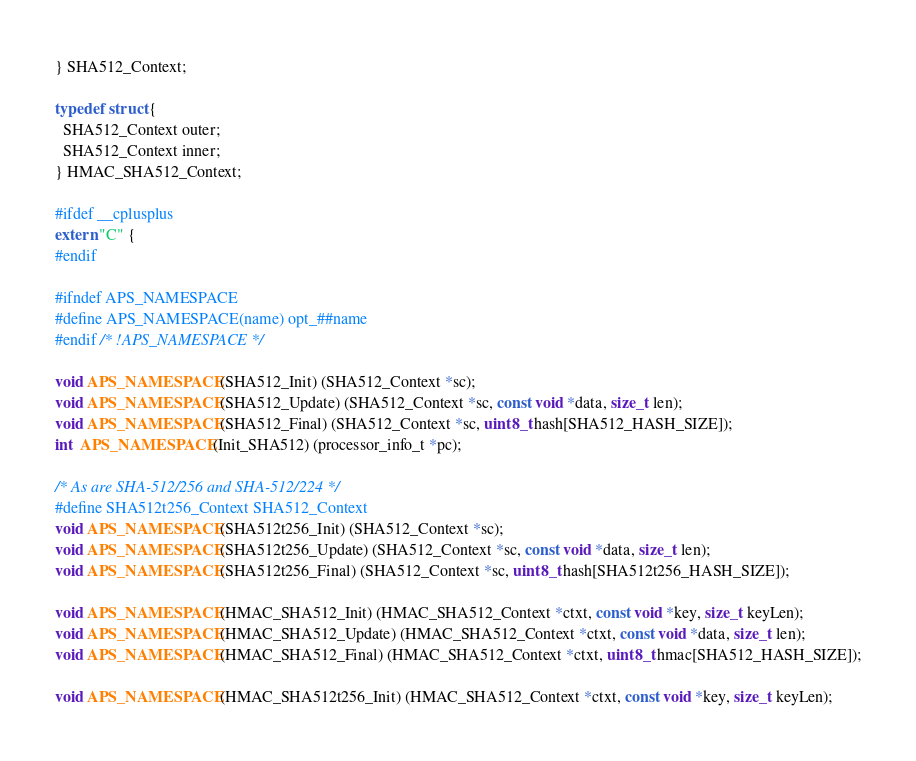<code> <loc_0><loc_0><loc_500><loc_500><_C_>} SHA512_Context;

typedef struct {
  SHA512_Context outer;
  SHA512_Context inner;
} HMAC_SHA512_Context;

#ifdef __cplusplus
extern "C" {
#endif

#ifndef APS_NAMESPACE
#define APS_NAMESPACE(name) opt_##name
#endif /* !APS_NAMESPACE */

void APS_NAMESPACE(SHA512_Init) (SHA512_Context *sc);
void APS_NAMESPACE(SHA512_Update) (SHA512_Context *sc, const void *data, size_t len);
void APS_NAMESPACE(SHA512_Final) (SHA512_Context *sc, uint8_t hash[SHA512_HASH_SIZE]);
int  APS_NAMESPACE(Init_SHA512) (processor_info_t *pc);

/* As are SHA-512/256 and SHA-512/224 */
#define SHA512t256_Context SHA512_Context
void APS_NAMESPACE(SHA512t256_Init) (SHA512_Context *sc);
void APS_NAMESPACE(SHA512t256_Update) (SHA512_Context *sc, const void *data, size_t len);
void APS_NAMESPACE(SHA512t256_Final) (SHA512_Context *sc, uint8_t hash[SHA512t256_HASH_SIZE]);

void APS_NAMESPACE(HMAC_SHA512_Init) (HMAC_SHA512_Context *ctxt, const void *key, size_t keyLen);
void APS_NAMESPACE(HMAC_SHA512_Update) (HMAC_SHA512_Context *ctxt, const void *data, size_t len);
void APS_NAMESPACE(HMAC_SHA512_Final) (HMAC_SHA512_Context *ctxt, uint8_t hmac[SHA512_HASH_SIZE]);

void APS_NAMESPACE(HMAC_SHA512t256_Init) (HMAC_SHA512_Context *ctxt, const void *key, size_t keyLen);</code> 